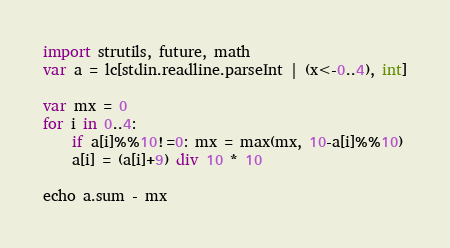Convert code to text. <code><loc_0><loc_0><loc_500><loc_500><_Nim_>import strutils, future, math
var a = lc[stdin.readline.parseInt | (x<-0..4), int]

var mx = 0
for i in 0..4:
    if a[i]%%10!=0: mx = max(mx, 10-a[i]%%10)
    a[i] = (a[i]+9) div 10 * 10

echo a.sum - mx</code> 